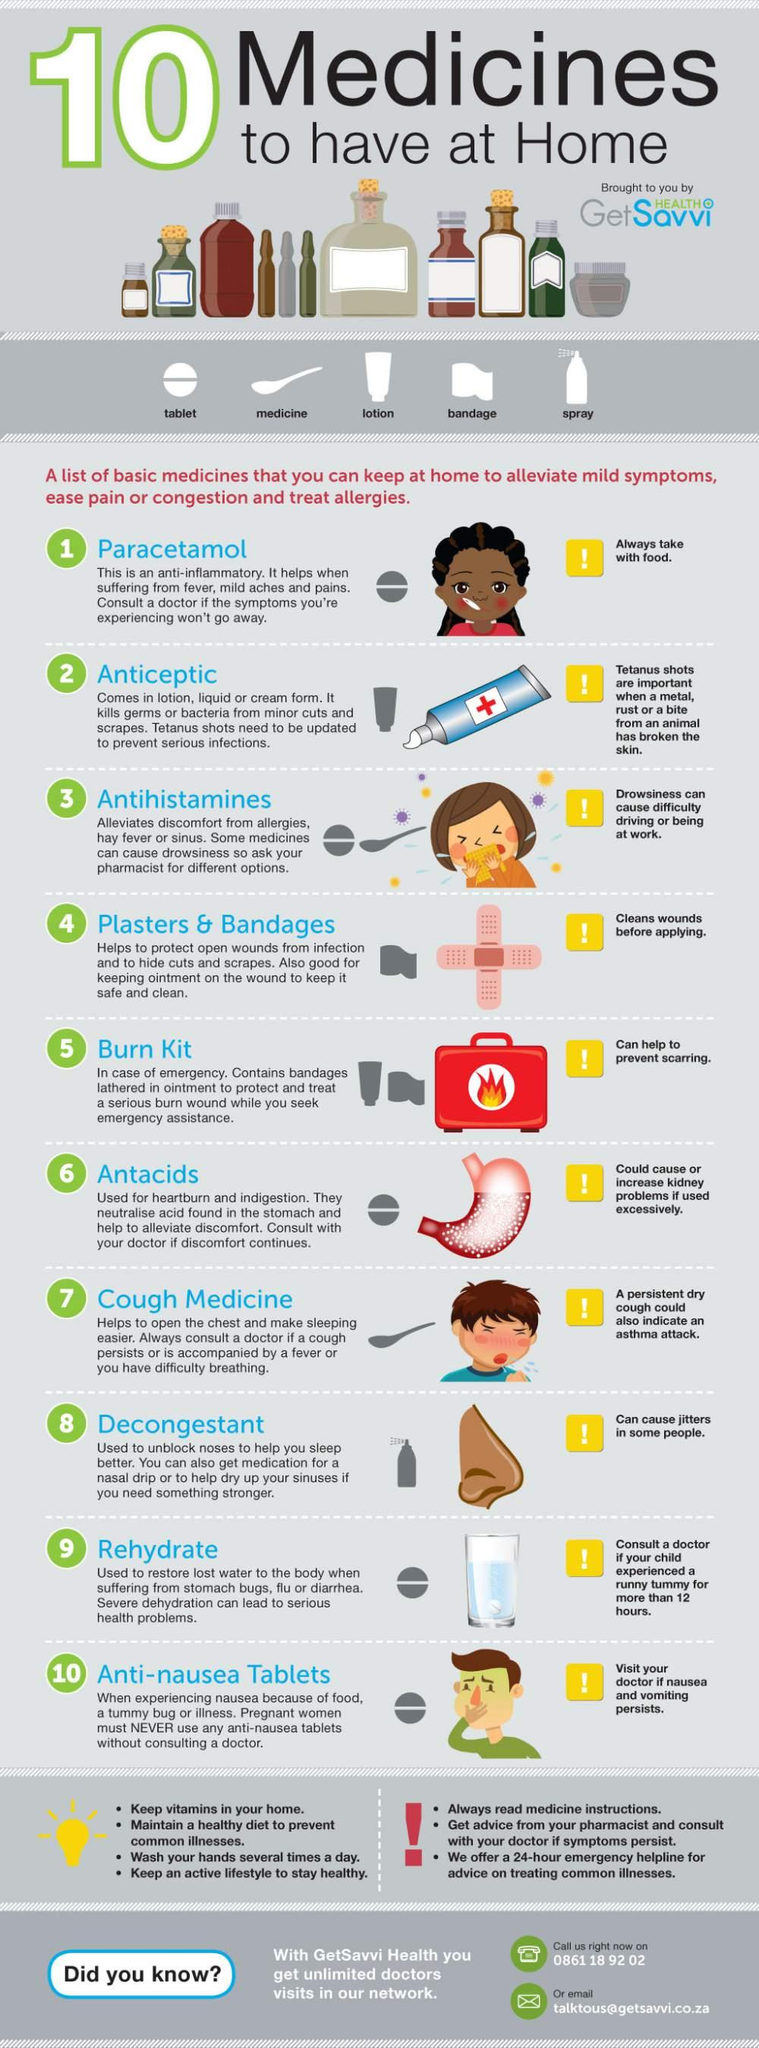Draw attention to some important aspects in this diagram. Decongestants can cause jitters in some individuals. The tube with the + sign on it is known as an antiseptic. Paracetamol should always be taken with food. Preventing scarring is important when treating burns. To help prevent scarring, using a burn kit can be beneficial. Antacids can cause or worsen kidney problems if used excessively, which is a critical factor to consider for individuals at risk of developing kidney-related complications. 